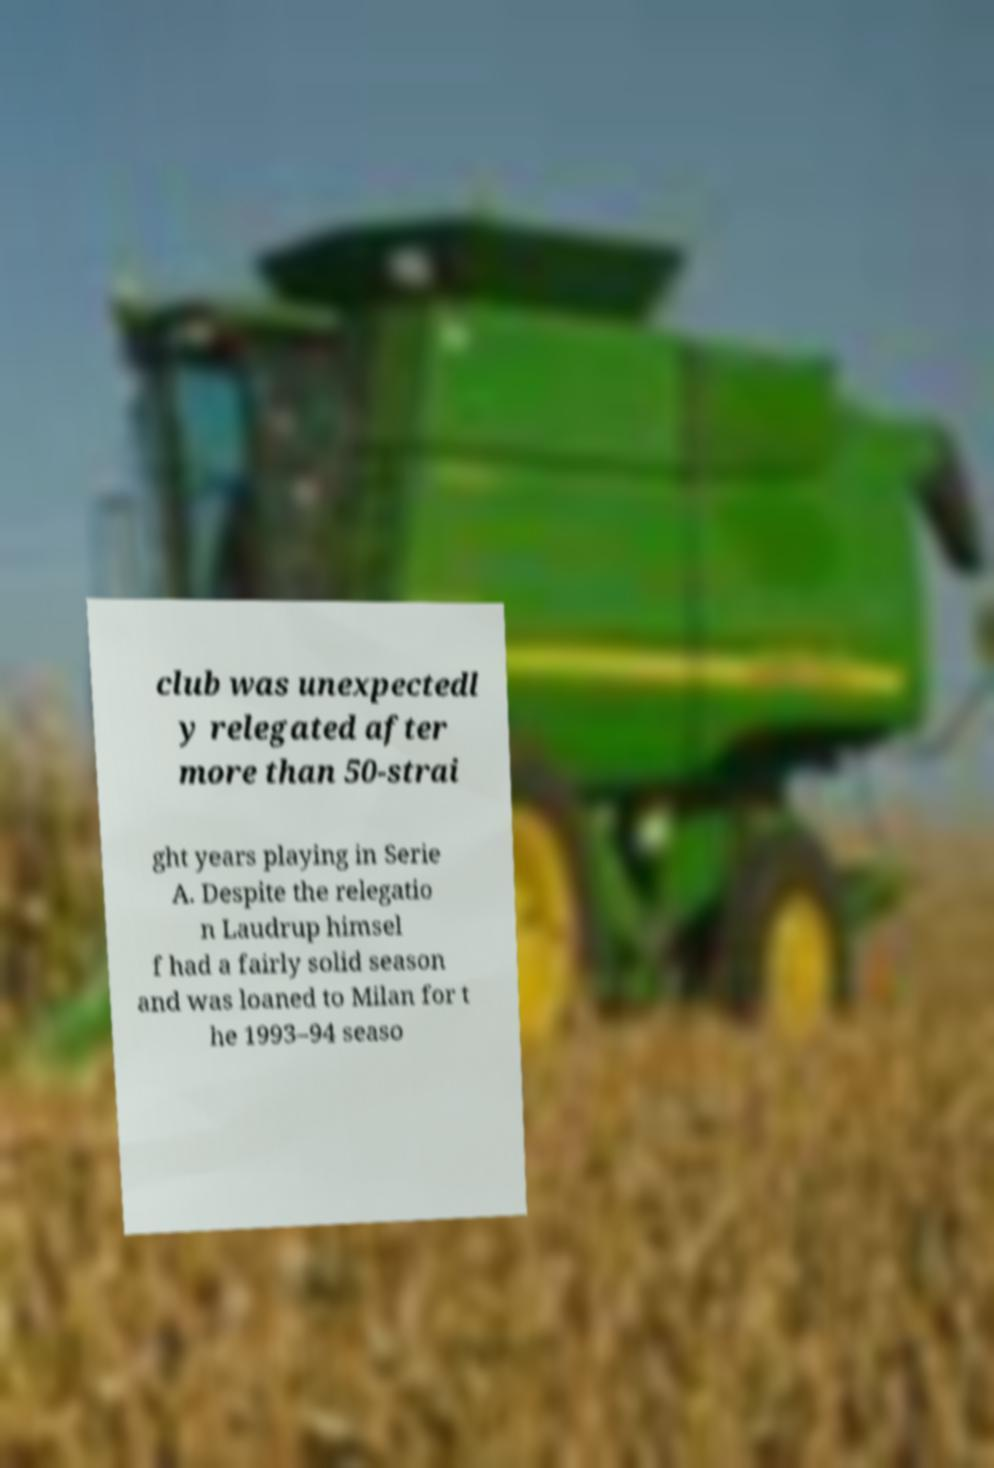I need the written content from this picture converted into text. Can you do that? club was unexpectedl y relegated after more than 50-strai ght years playing in Serie A. Despite the relegatio n Laudrup himsel f had a fairly solid season and was loaned to Milan for t he 1993–94 seaso 